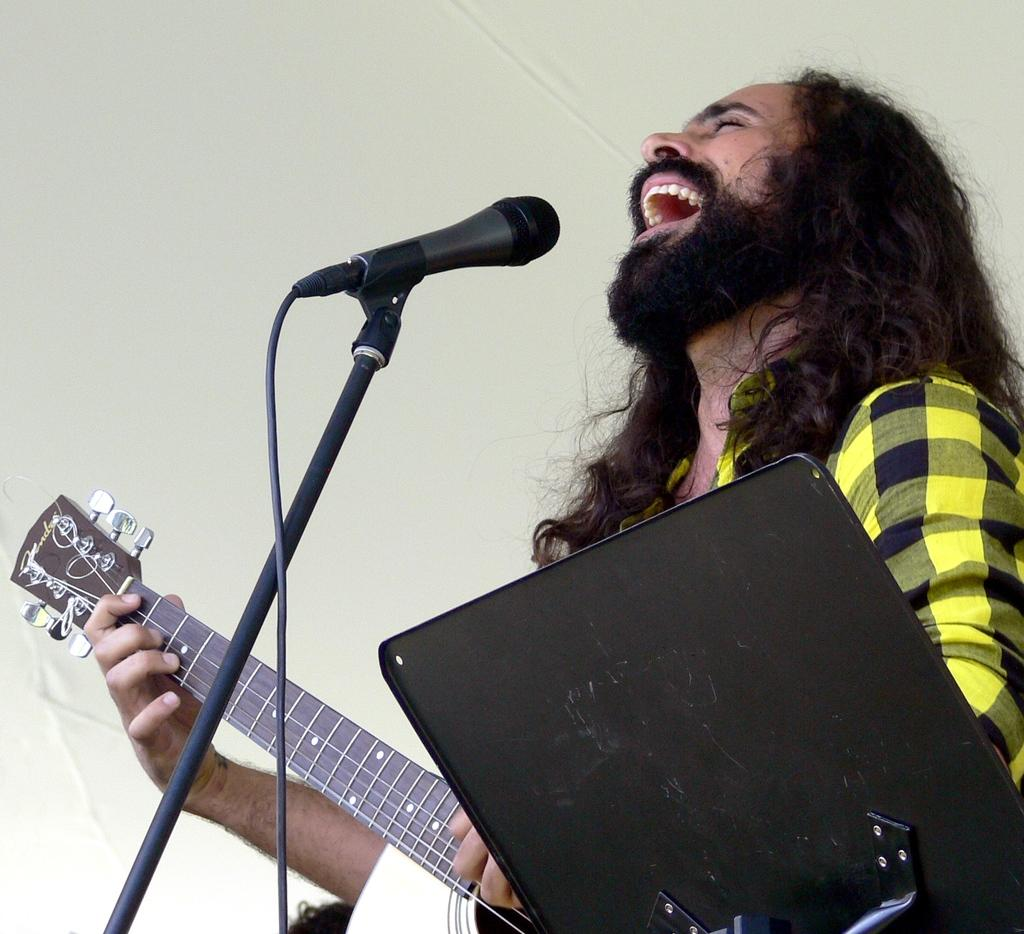What is the man in the image doing? The man is playing a guitar and singing. What instrument is the man playing in the image? The man is playing a guitar. What device is present for amplifying the man's voice in the image? There is a microphone in the image. How is the microphone positioned in the image? There is a mic holder in the image. What type of print can be seen on the man's shirt in the image? There is no information about the man's shirt or any print on it in the provided facts. --- Facts: 1. There is a car in the image. 2. The car is red. 3. The car has four wheels. 4. There is a road in the image. 5. The road is paved. Absurd Topics: parrot, ocean, dance Conversation: What is the color of the car in the image? The car is red. How many wheels does the car in the image have? The car has four wheels. What type of surface is the car driving on in the image? The car is driving on a paved road. Reasoning: Let's think step by step in order to produce the conversation. We start by identifying the main subject in the image, which is the car. Then, we describe the color and number of wheels of the car. Finally, we mention the type of surface the car is driving on, which is a paved road. Each question is designed to elicit a specific detail about the image that is known from the provided facts. Absurd Question/Answer: Can you see a parrot flying over the ocean in the image? There is no mention of a parrot or an ocean in the provided facts, so it cannot be determined from the image. 